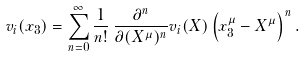Convert formula to latex. <formula><loc_0><loc_0><loc_500><loc_500>v _ { i } ( x _ { 3 } ) = \sum _ { n = 0 } ^ { \infty } \frac { 1 } { n ! } \, \frac { \partial ^ { n } } { \partial ( X ^ { \mu } ) ^ { n } } v _ { i } ( X ) \left ( x _ { 3 } ^ { \mu } - X ^ { \mu } \right ) ^ { n } .</formula> 